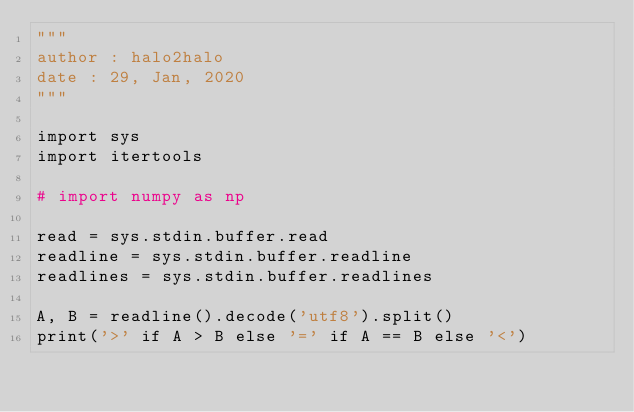Convert code to text. <code><loc_0><loc_0><loc_500><loc_500><_Python_>"""
author : halo2halo
date : 29, Jan, 2020
"""

import sys
import itertools

# import numpy as np

read = sys.stdin.buffer.read
readline = sys.stdin.buffer.readline
readlines = sys.stdin.buffer.readlines

A, B = readline().decode('utf8').split()
print('>' if A > B else '=' if A == B else '<')
</code> 